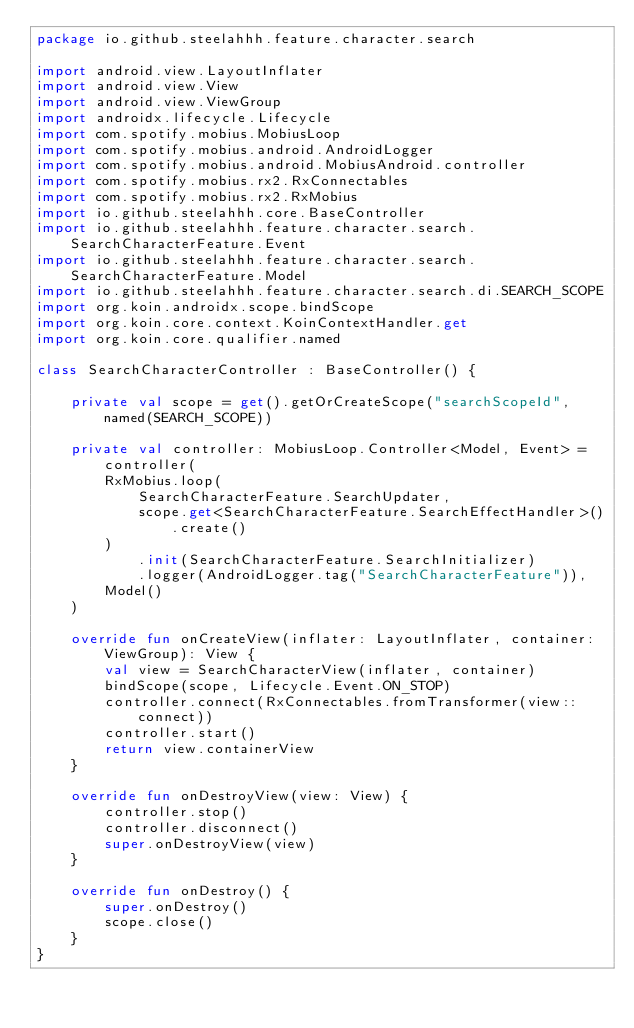Convert code to text. <code><loc_0><loc_0><loc_500><loc_500><_Kotlin_>package io.github.steelahhh.feature.character.search

import android.view.LayoutInflater
import android.view.View
import android.view.ViewGroup
import androidx.lifecycle.Lifecycle
import com.spotify.mobius.MobiusLoop
import com.spotify.mobius.android.AndroidLogger
import com.spotify.mobius.android.MobiusAndroid.controller
import com.spotify.mobius.rx2.RxConnectables
import com.spotify.mobius.rx2.RxMobius
import io.github.steelahhh.core.BaseController
import io.github.steelahhh.feature.character.search.SearchCharacterFeature.Event
import io.github.steelahhh.feature.character.search.SearchCharacterFeature.Model
import io.github.steelahhh.feature.character.search.di.SEARCH_SCOPE
import org.koin.androidx.scope.bindScope
import org.koin.core.context.KoinContextHandler.get
import org.koin.core.qualifier.named

class SearchCharacterController : BaseController() {

    private val scope = get().getOrCreateScope("searchScopeId", named(SEARCH_SCOPE))

    private val controller: MobiusLoop.Controller<Model, Event> = controller(
        RxMobius.loop(
            SearchCharacterFeature.SearchUpdater,
            scope.get<SearchCharacterFeature.SearchEffectHandler>().create()
        )
            .init(SearchCharacterFeature.SearchInitializer)
            .logger(AndroidLogger.tag("SearchCharacterFeature")),
        Model()
    )

    override fun onCreateView(inflater: LayoutInflater, container: ViewGroup): View {
        val view = SearchCharacterView(inflater, container)
        bindScope(scope, Lifecycle.Event.ON_STOP)
        controller.connect(RxConnectables.fromTransformer(view::connect))
        controller.start()
        return view.containerView
    }

    override fun onDestroyView(view: View) {
        controller.stop()
        controller.disconnect()
        super.onDestroyView(view)
    }

    override fun onDestroy() {
        super.onDestroy()
        scope.close()
    }
}
</code> 